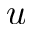Convert formula to latex. <formula><loc_0><loc_0><loc_500><loc_500>u</formula> 